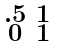<formula> <loc_0><loc_0><loc_500><loc_500>\begin{smallmatrix} . 5 & 1 \\ 0 & 1 \end{smallmatrix}</formula> 